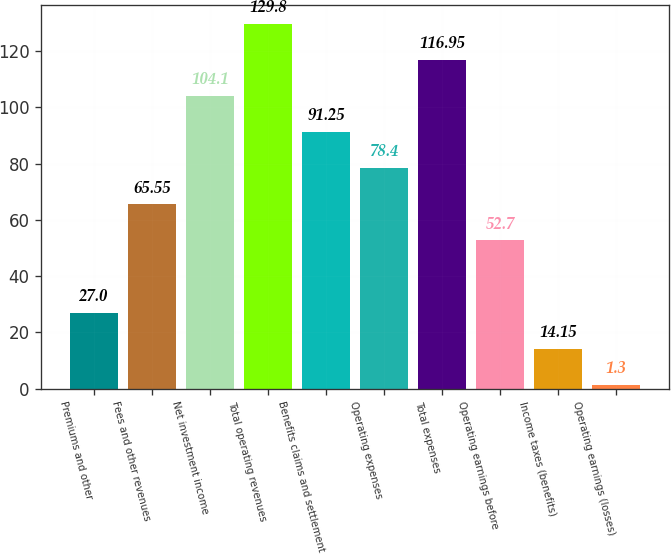Convert chart. <chart><loc_0><loc_0><loc_500><loc_500><bar_chart><fcel>Premiums and other<fcel>Fees and other revenues<fcel>Net investment income<fcel>Total operating revenues<fcel>Benefits claims and settlement<fcel>Operating expenses<fcel>Total expenses<fcel>Operating earnings before<fcel>Income taxes (benefits)<fcel>Operating earnings (losses)<nl><fcel>27<fcel>65.55<fcel>104.1<fcel>129.8<fcel>91.25<fcel>78.4<fcel>116.95<fcel>52.7<fcel>14.15<fcel>1.3<nl></chart> 